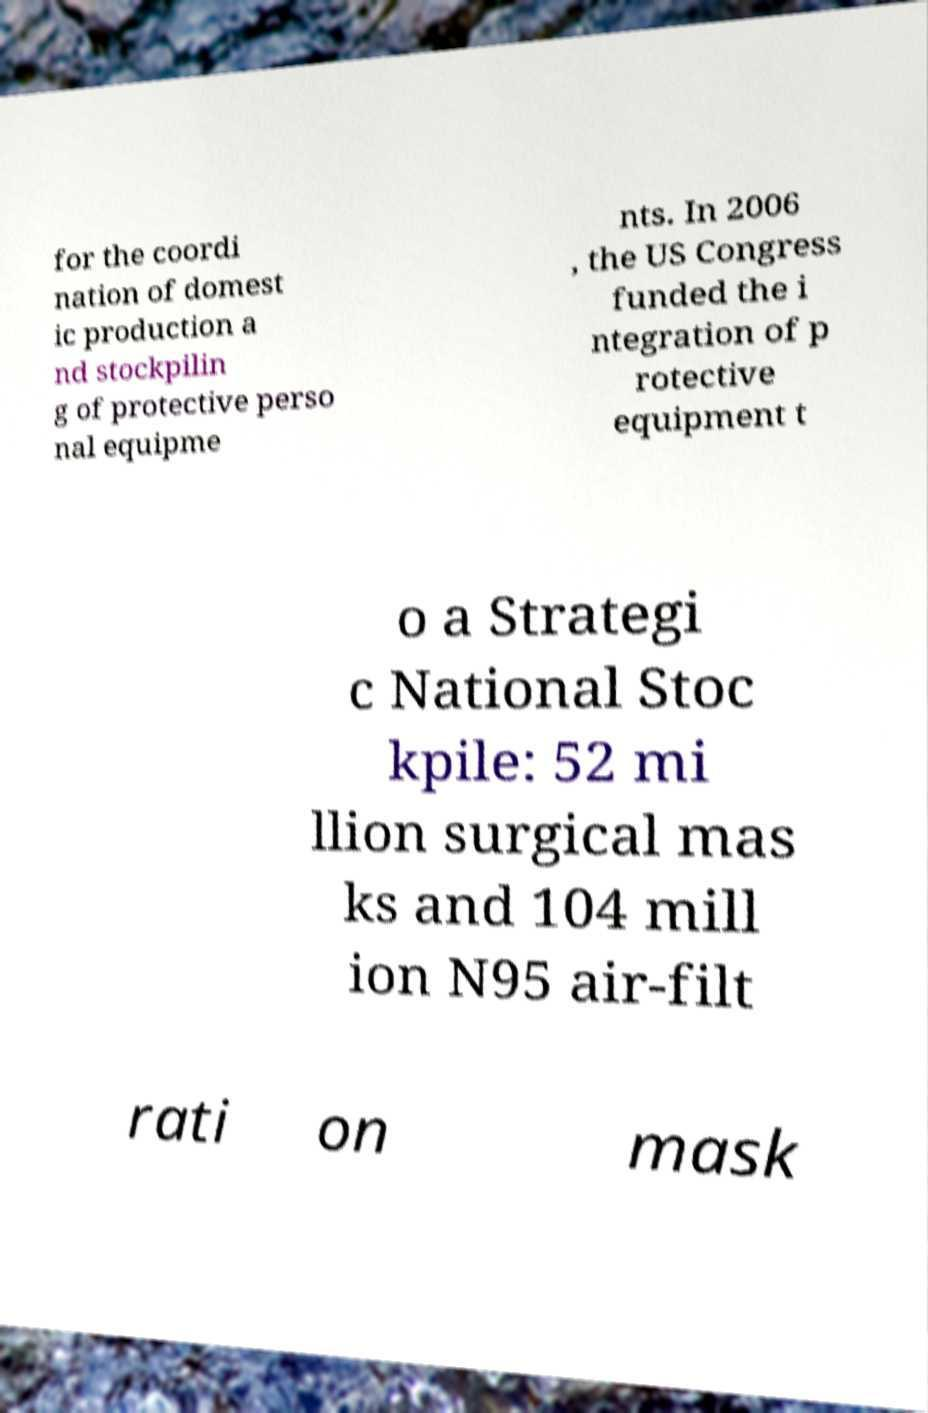Can you read and provide the text displayed in the image?This photo seems to have some interesting text. Can you extract and type it out for me? for the coordi nation of domest ic production a nd stockpilin g of protective perso nal equipme nts. In 2006 , the US Congress funded the i ntegration of p rotective equipment t o a Strategi c National Stoc kpile: 52 mi llion surgical mas ks and 104 mill ion N95 air-filt rati on mask 